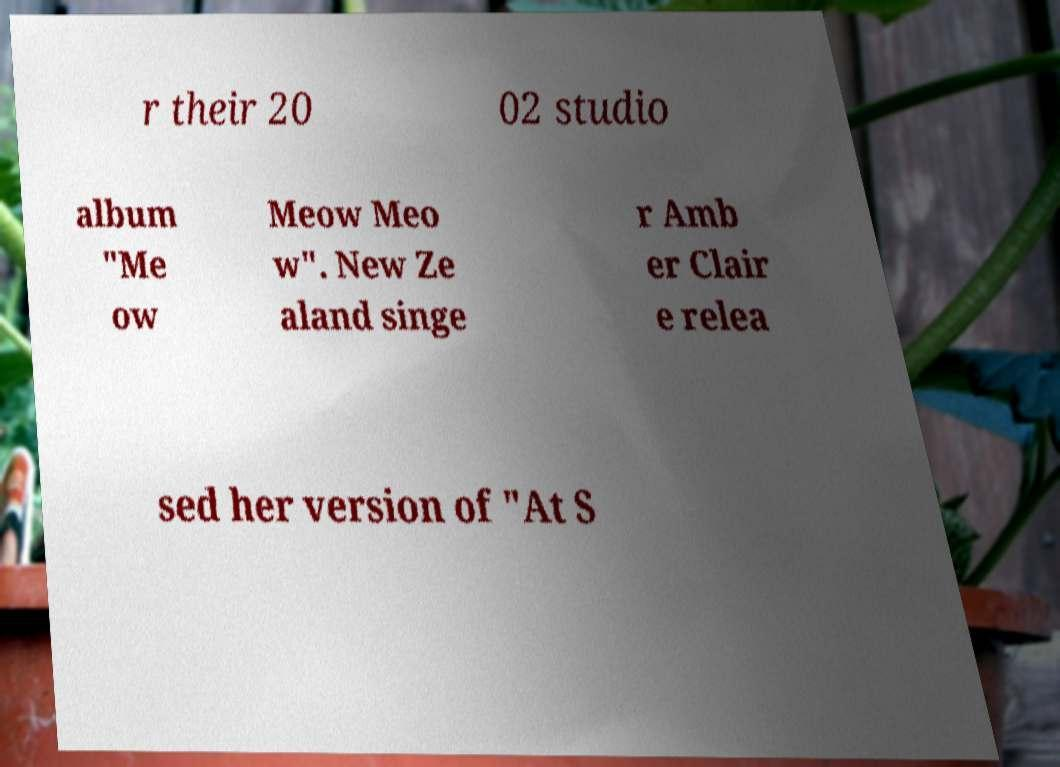What messages or text are displayed in this image? I need them in a readable, typed format. r their 20 02 studio album "Me ow Meow Meo w". New Ze aland singe r Amb er Clair e relea sed her version of "At S 